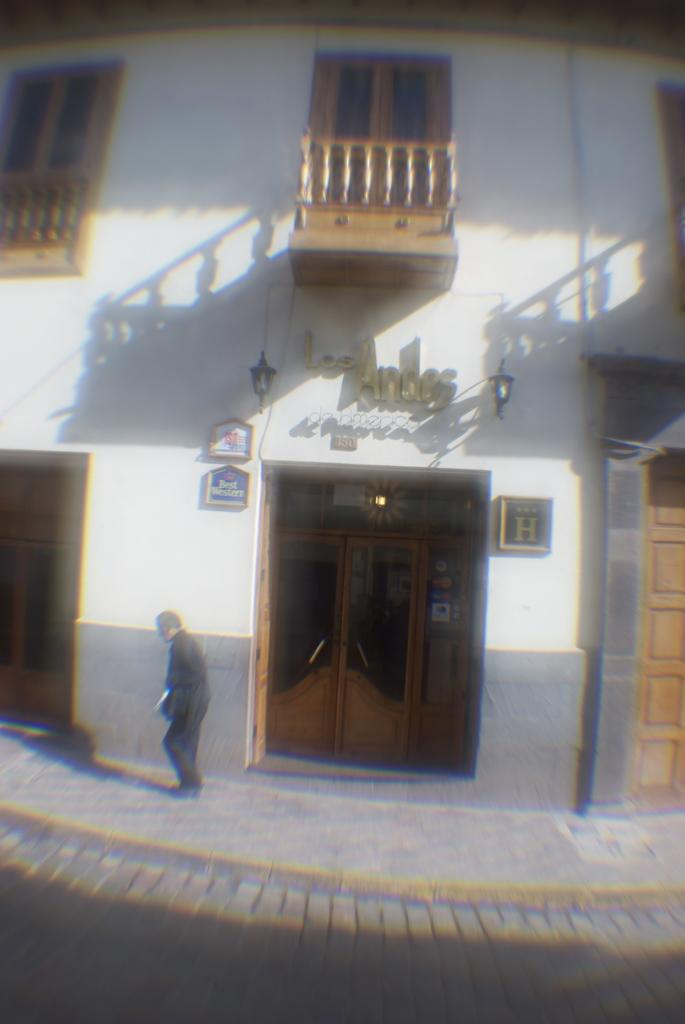Where is the man located in the image? The man is at the bottom of the image on the footpath. What is behind the man in the image? There is a wall behind the man. What features can be seen on the wall in the image? The wall has doors, windows, railings, lamps, and frames. How many snakes are crawling on the wall in the image? There are no snakes present in the image. What word is written on the wall in the image? There is no word written on the wall in the image. 